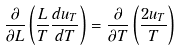Convert formula to latex. <formula><loc_0><loc_0><loc_500><loc_500>\frac { \partial } { \partial L } \left ( \frac { L } { T } \frac { d u _ { T } } { d T } \right ) = \frac { \partial } { \partial T } \left ( \frac { 2 u _ { T } } { T } \right )</formula> 